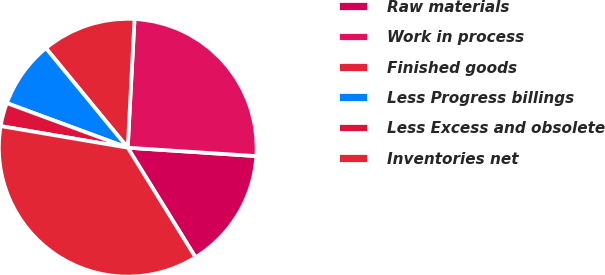<chart> <loc_0><loc_0><loc_500><loc_500><pie_chart><fcel>Raw materials<fcel>Work in process<fcel>Finished goods<fcel>Less Progress billings<fcel>Less Excess and obsolete<fcel>Inventories net<nl><fcel>15.15%<fcel>25.2%<fcel>11.79%<fcel>8.43%<fcel>2.94%<fcel>36.5%<nl></chart> 